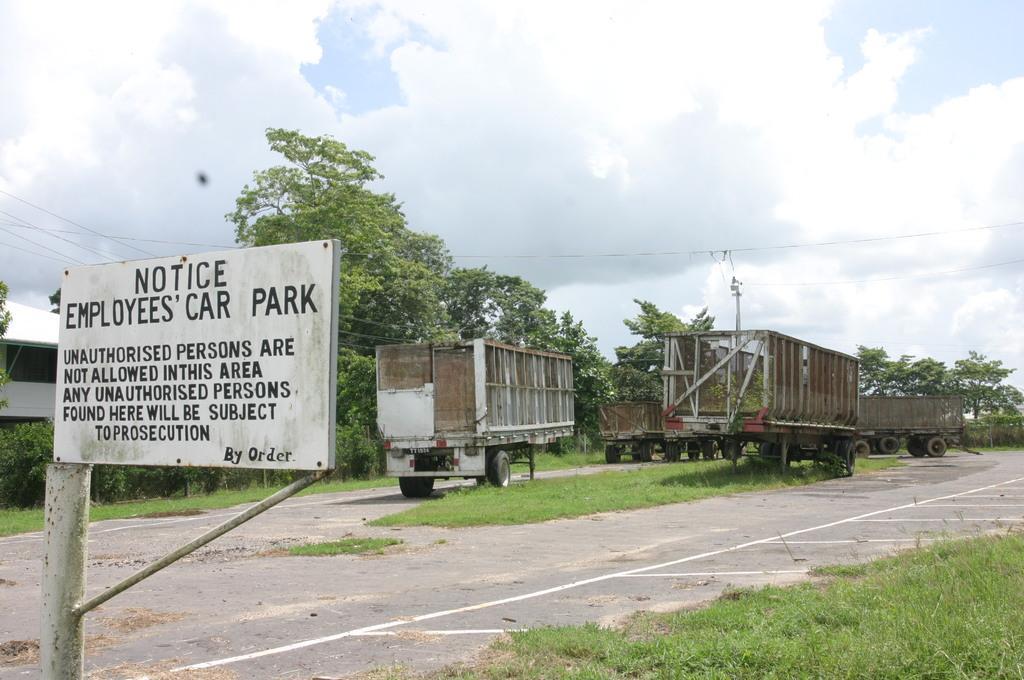Please provide a concise description of this image. In this image we can see some railroad cars. At the bottom of the image there is a grass and a road. On the left side of the image there is a name board and other objects. In the background of the image there are some trees, pole and cables. At the top of the image there is the sky. 